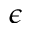Convert formula to latex. <formula><loc_0><loc_0><loc_500><loc_500>\epsilon</formula> 